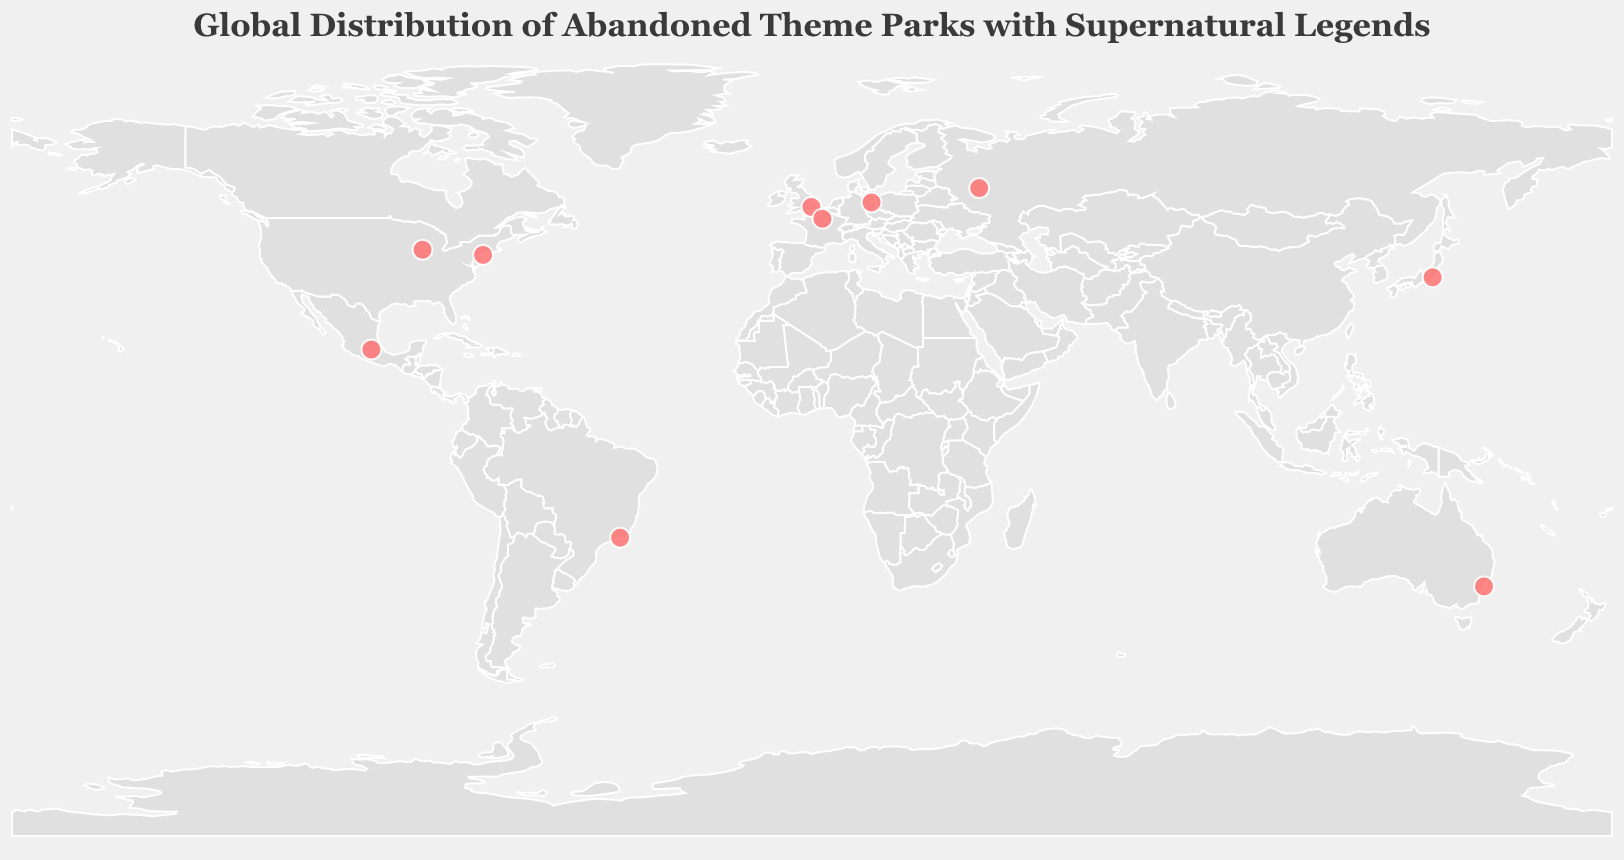How many parks with supernatural legends are marked on the map? There are red circles marking each park with a supernatural legend. Count the number of red circle markers.
Answer: 10 Which city in Japan hosts an abandoned theme park with supernatural legends according to the map? Look for the marker in Japan and check its tooltip information to identify the city. The tooltip for Japan indicates "Nara Dreamland" in Nara, Japan.
Answer: Nara What type of supernatural legend is associated with "Spreepark" in Germany? Find the marker located in Germany and hover over it to see the tooltip. The tooltip for "Spreepark" in Germany mentions the supernatural legend.
Answer: Whispering winds carry voices of lost children How many parks in the USA are shown on the map with supernatural legends? Identify the markers located in the USA by their coordinates or tooltip information. There are two parks identified: "Kiddieland" in Chicago and "Astroland" in New York City.
Answer: 2 Which continent has the highest concentration of abandoned theme parks with supernatural legends? By visually inspecting the map, note the distribution of markers across different continents. The continent with the highest concentration of markers is North America.
Answer: North America Are there any abandoned theme parks with supernatural legends on the African continent shown in the figure? Observe the entire African continent on the map and look for any markers. No markers are present on the African continent.
Answer: No Which theme park has the legend of "Radioactive spirits roaming at night"? Hover over each marker and read the tooltip information to find the park with this legend, which is identified as "Chernobyl Amusement Park" in Ukraine.
Answer: Chernobyl Amusement Park What is the name of the theme park located in Brazil and its associated supernatural legend? Locate the marker in Brazil and hover over it to read the tooltip, which provides the name and legend. The park is "Tivoli Park" and its legend is "Phantom train still runs on overgrown tracks."
Answer: Tivoli Park, Phantom train still runs on overgrown tracks Which theme park located in Australia has a supernatural legend, and what's the legend specifically? Find the marker on Australia’s east coast and read its tooltip. The park is "Wonderland Sydney" and the legend is "Vanishing visitors near abandoned ferris wheel."
Answer: Wonderland Sydney, Vanishing visitors near abandoned ferris wheel 